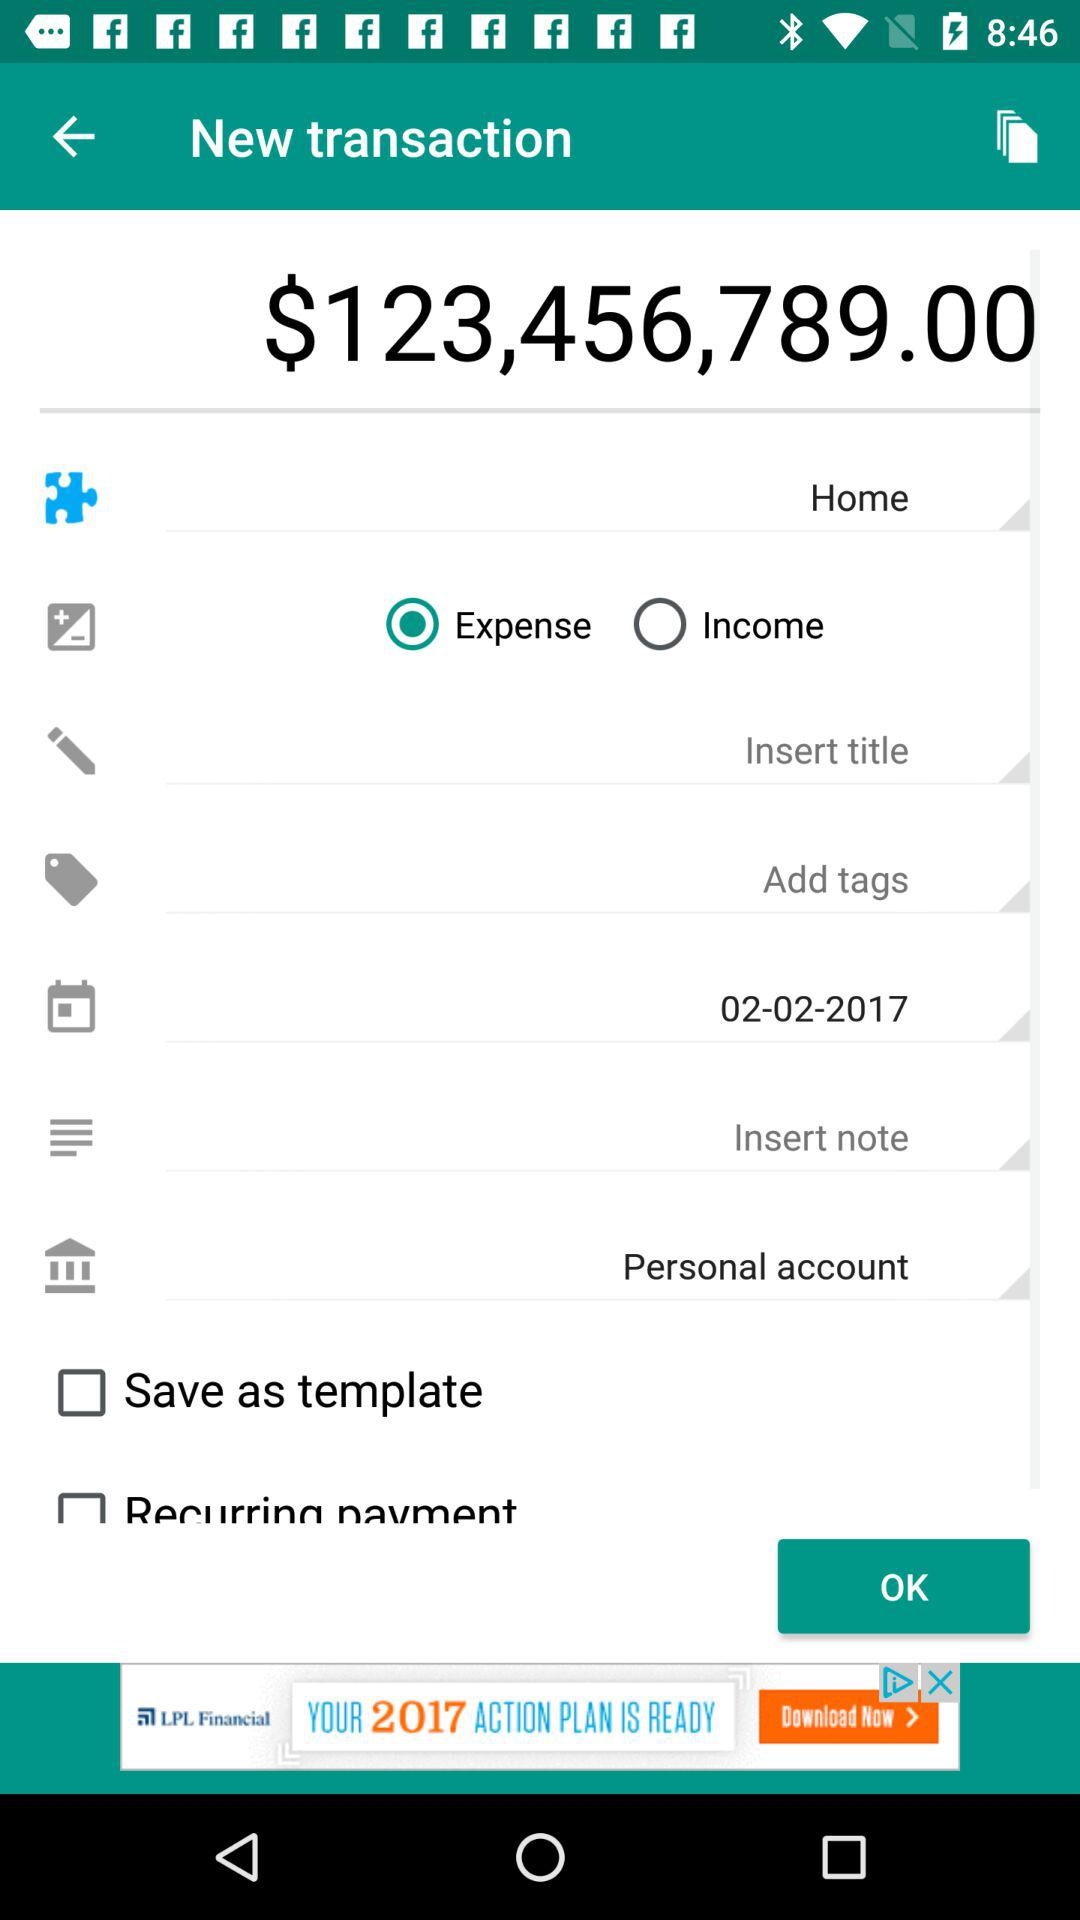How much is the current balance?
Answer the question using a single word or phrase. $123,456,789.00 